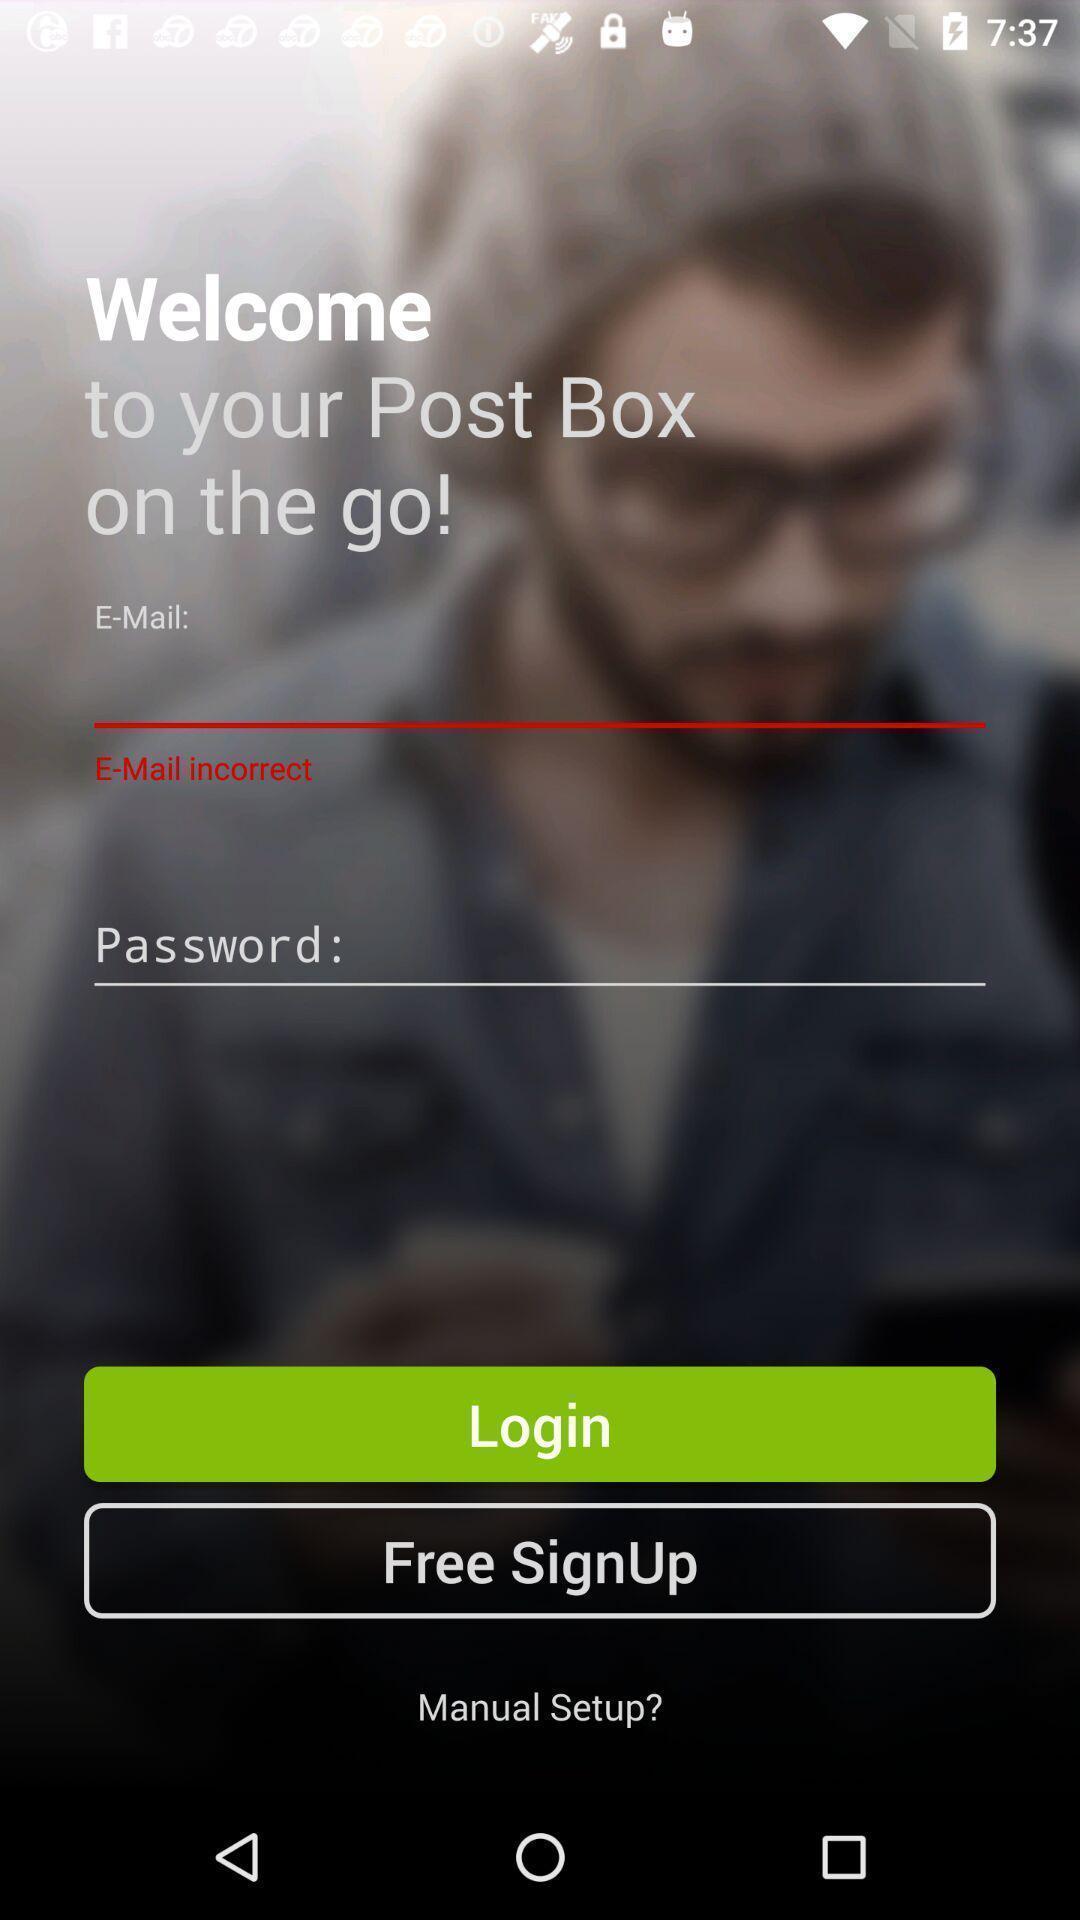Tell me what you see in this picture. Welcome and log-in page for an application. 